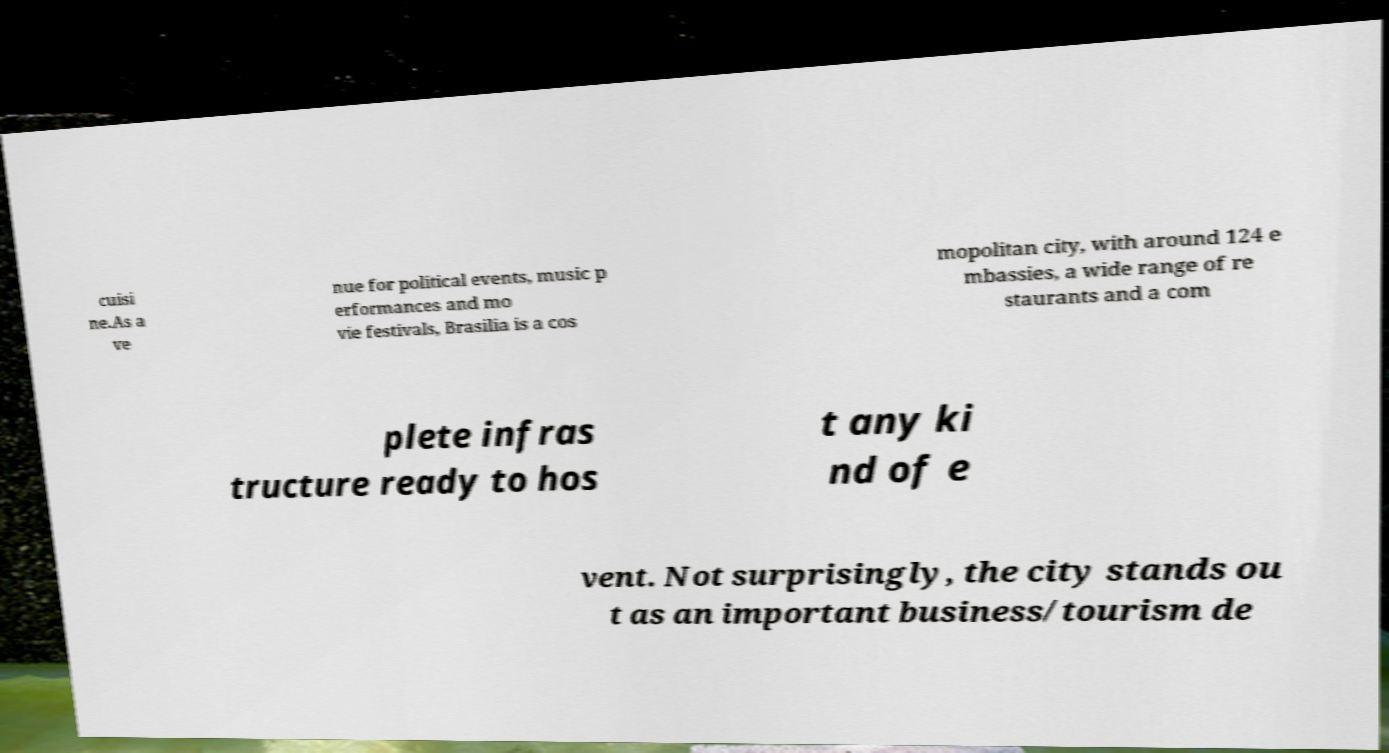Could you assist in decoding the text presented in this image and type it out clearly? cuisi ne.As a ve nue for political events, music p erformances and mo vie festivals, Brasilia is a cos mopolitan city, with around 124 e mbassies, a wide range of re staurants and a com plete infras tructure ready to hos t any ki nd of e vent. Not surprisingly, the city stands ou t as an important business/tourism de 